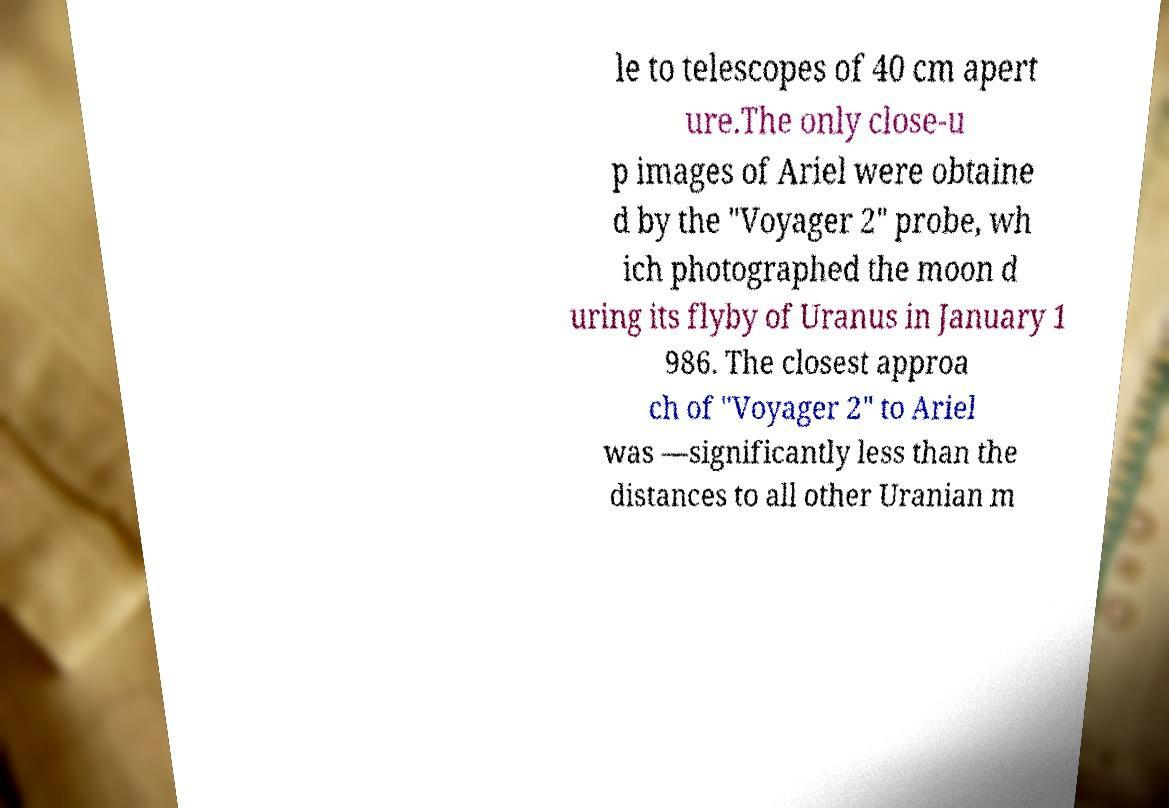For documentation purposes, I need the text within this image transcribed. Could you provide that? le to telescopes of 40 cm apert ure.The only close-u p images of Ariel were obtaine d by the "Voyager 2" probe, wh ich photographed the moon d uring its flyby of Uranus in January 1 986. The closest approa ch of "Voyager 2" to Ariel was —significantly less than the distances to all other Uranian m 